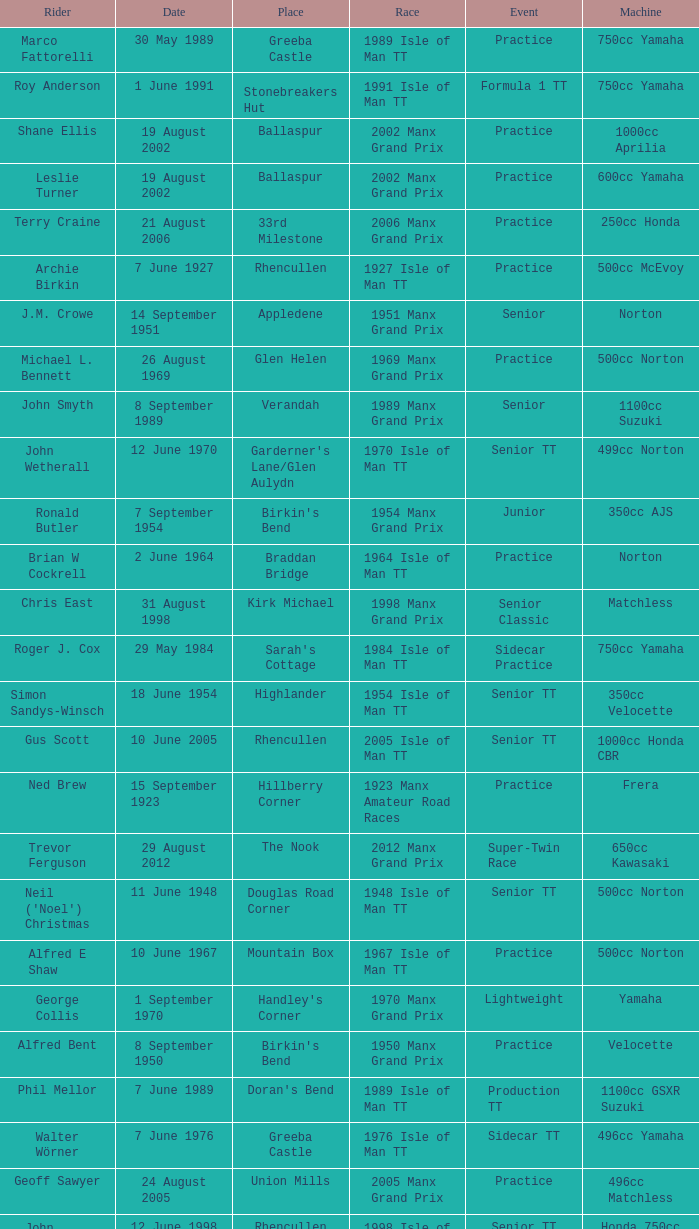What machine did Kenneth E. Herbert ride? 499cc Norton. 